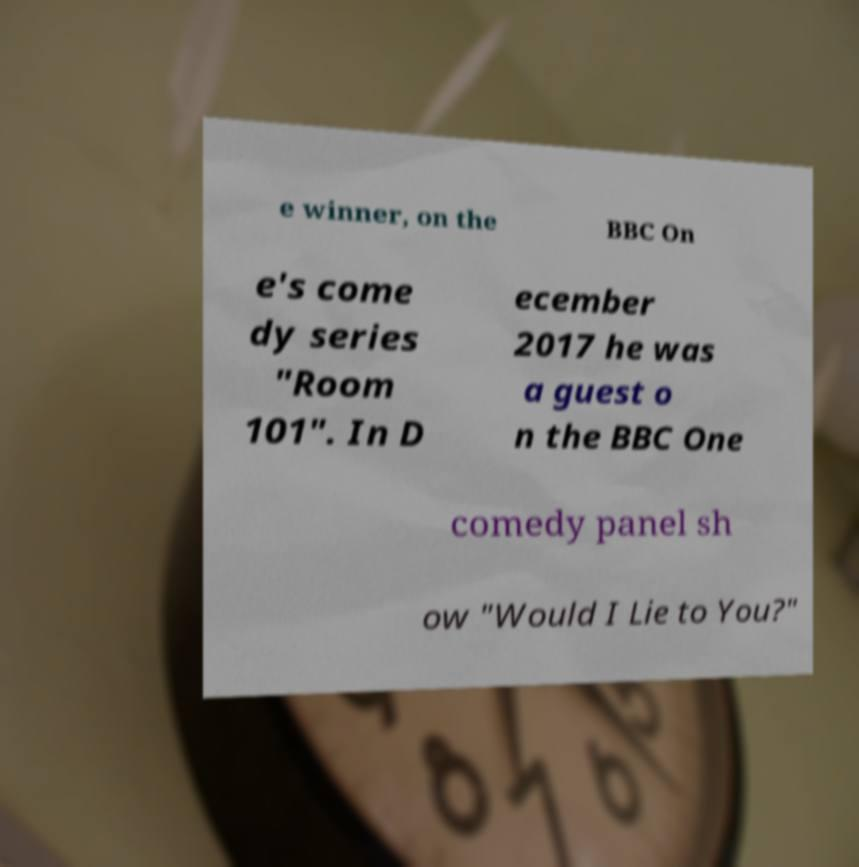For documentation purposes, I need the text within this image transcribed. Could you provide that? e winner, on the BBC On e's come dy series "Room 101". In D ecember 2017 he was a guest o n the BBC One comedy panel sh ow "Would I Lie to You?" 